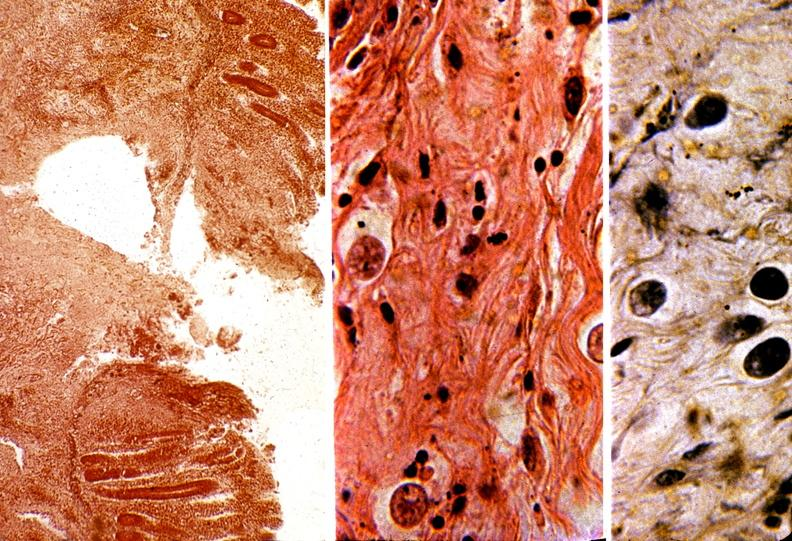what does this image show?
Answer the question using a single word or phrase. Colon 